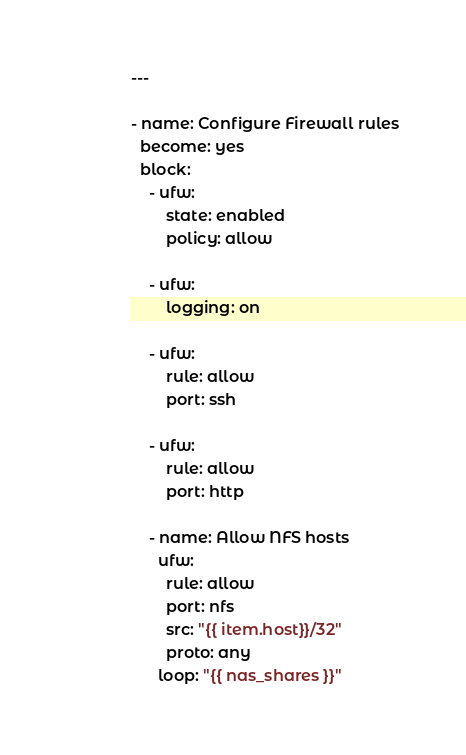Convert code to text. <code><loc_0><loc_0><loc_500><loc_500><_YAML_>---

- name: Configure Firewall rules
  become: yes
  block:
    - ufw:
        state: enabled
        policy: allow

    - ufw:
        logging: on

    - ufw:
        rule: allow
        port: ssh

    - ufw:
        rule: allow
        port: http

    - name: Allow NFS hosts
      ufw:
        rule: allow
        port: nfs
        src: "{{ item.host}}/32"
        proto: any
      loop: "{{ nas_shares }}"
</code> 